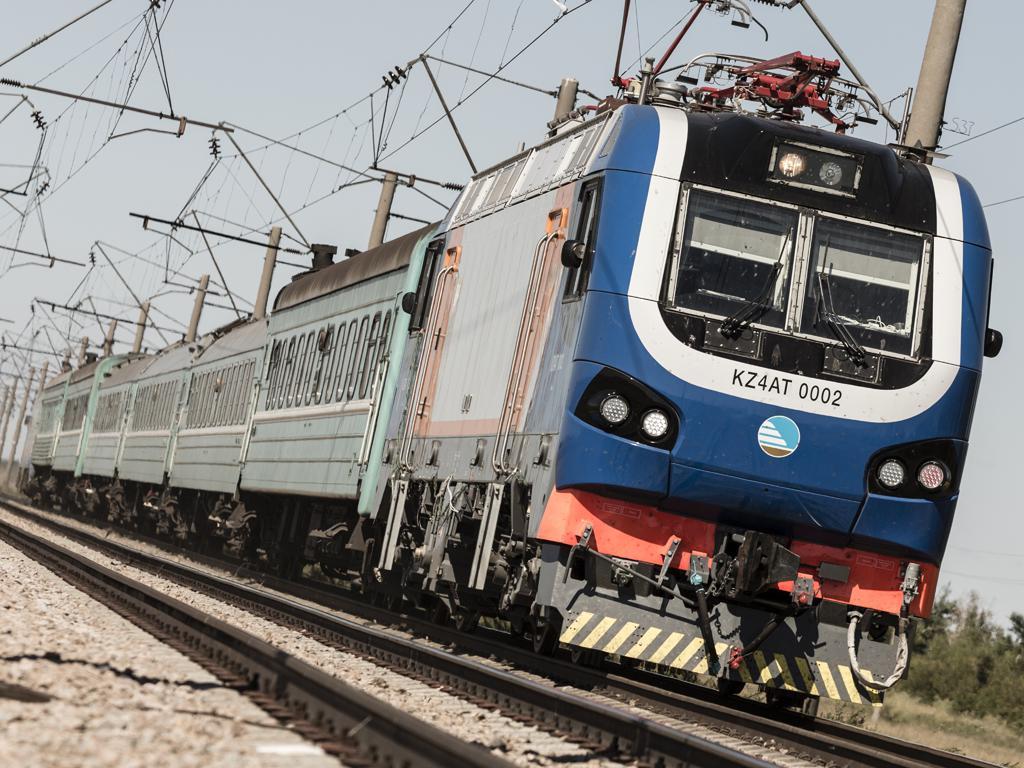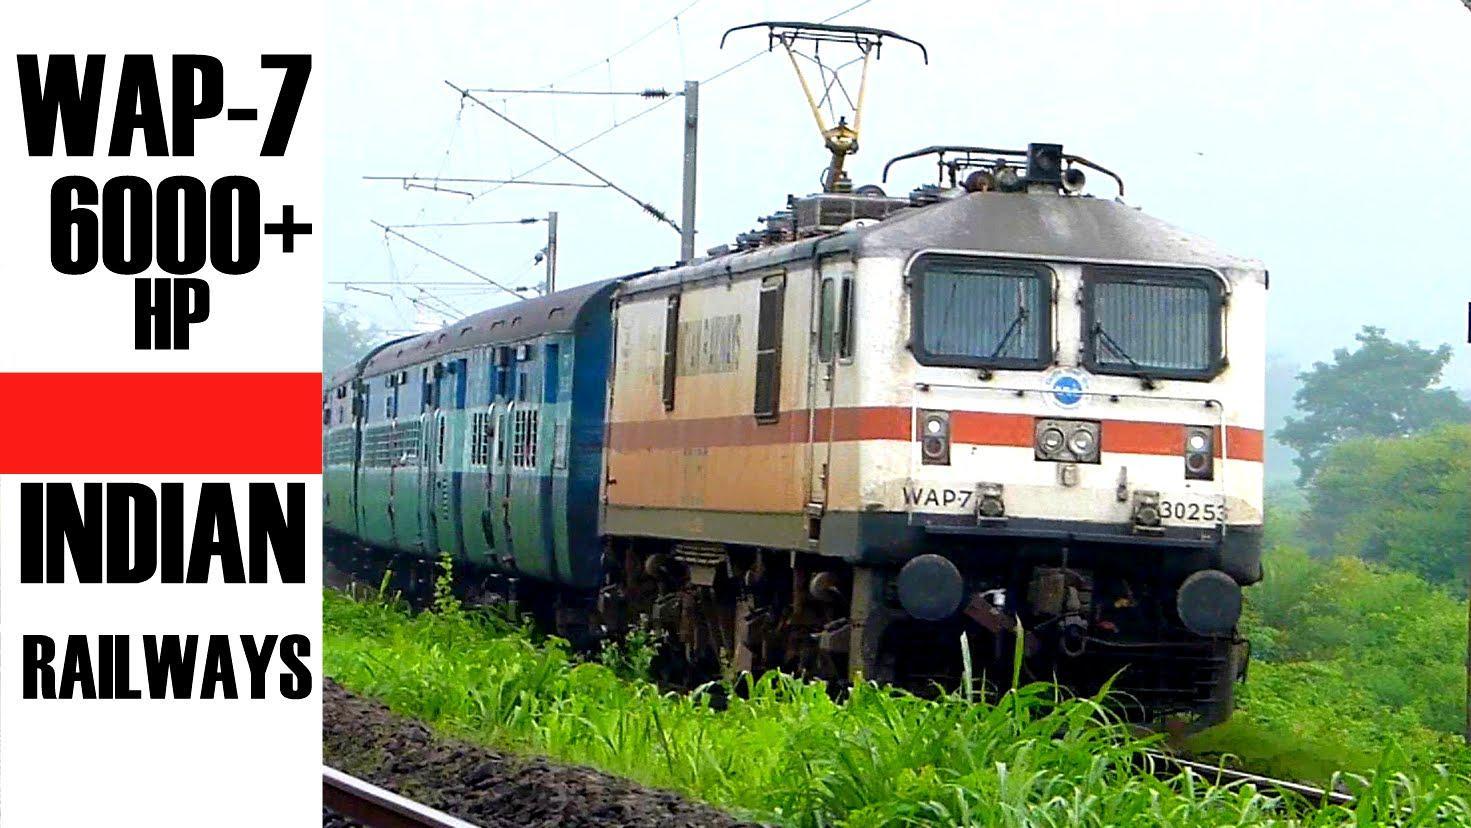The first image is the image on the left, the second image is the image on the right. Evaluate the accuracy of this statement regarding the images: "Both images show a train with at least one train car, and both trains are headed in the same direction and will not collide.". Is it true? Answer yes or no. Yes. The first image is the image on the left, the second image is the image on the right. Assess this claim about the two images: "The train in on the track in the image on the right is primarily yellow.". Correct or not? Answer yes or no. No. 